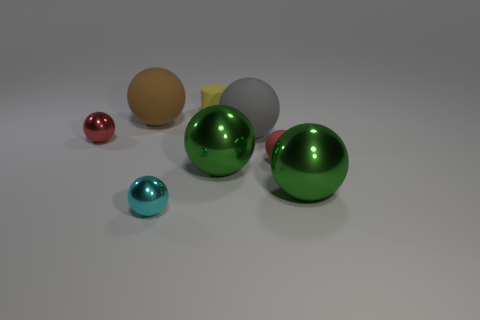Subtract all gray spheres. How many spheres are left? 6 Subtract all large green spheres. How many spheres are left? 5 Add 1 yellow rubber things. How many objects exist? 9 Subtract all cyan cylinders. Subtract all yellow spheres. How many cylinders are left? 1 Subtract all spheres. How many objects are left? 1 Add 6 cyan shiny balls. How many cyan shiny balls are left? 7 Add 2 rubber spheres. How many rubber spheres exist? 5 Subtract 0 purple spheres. How many objects are left? 8 Subtract all big cyan balls. Subtract all tiny things. How many objects are left? 4 